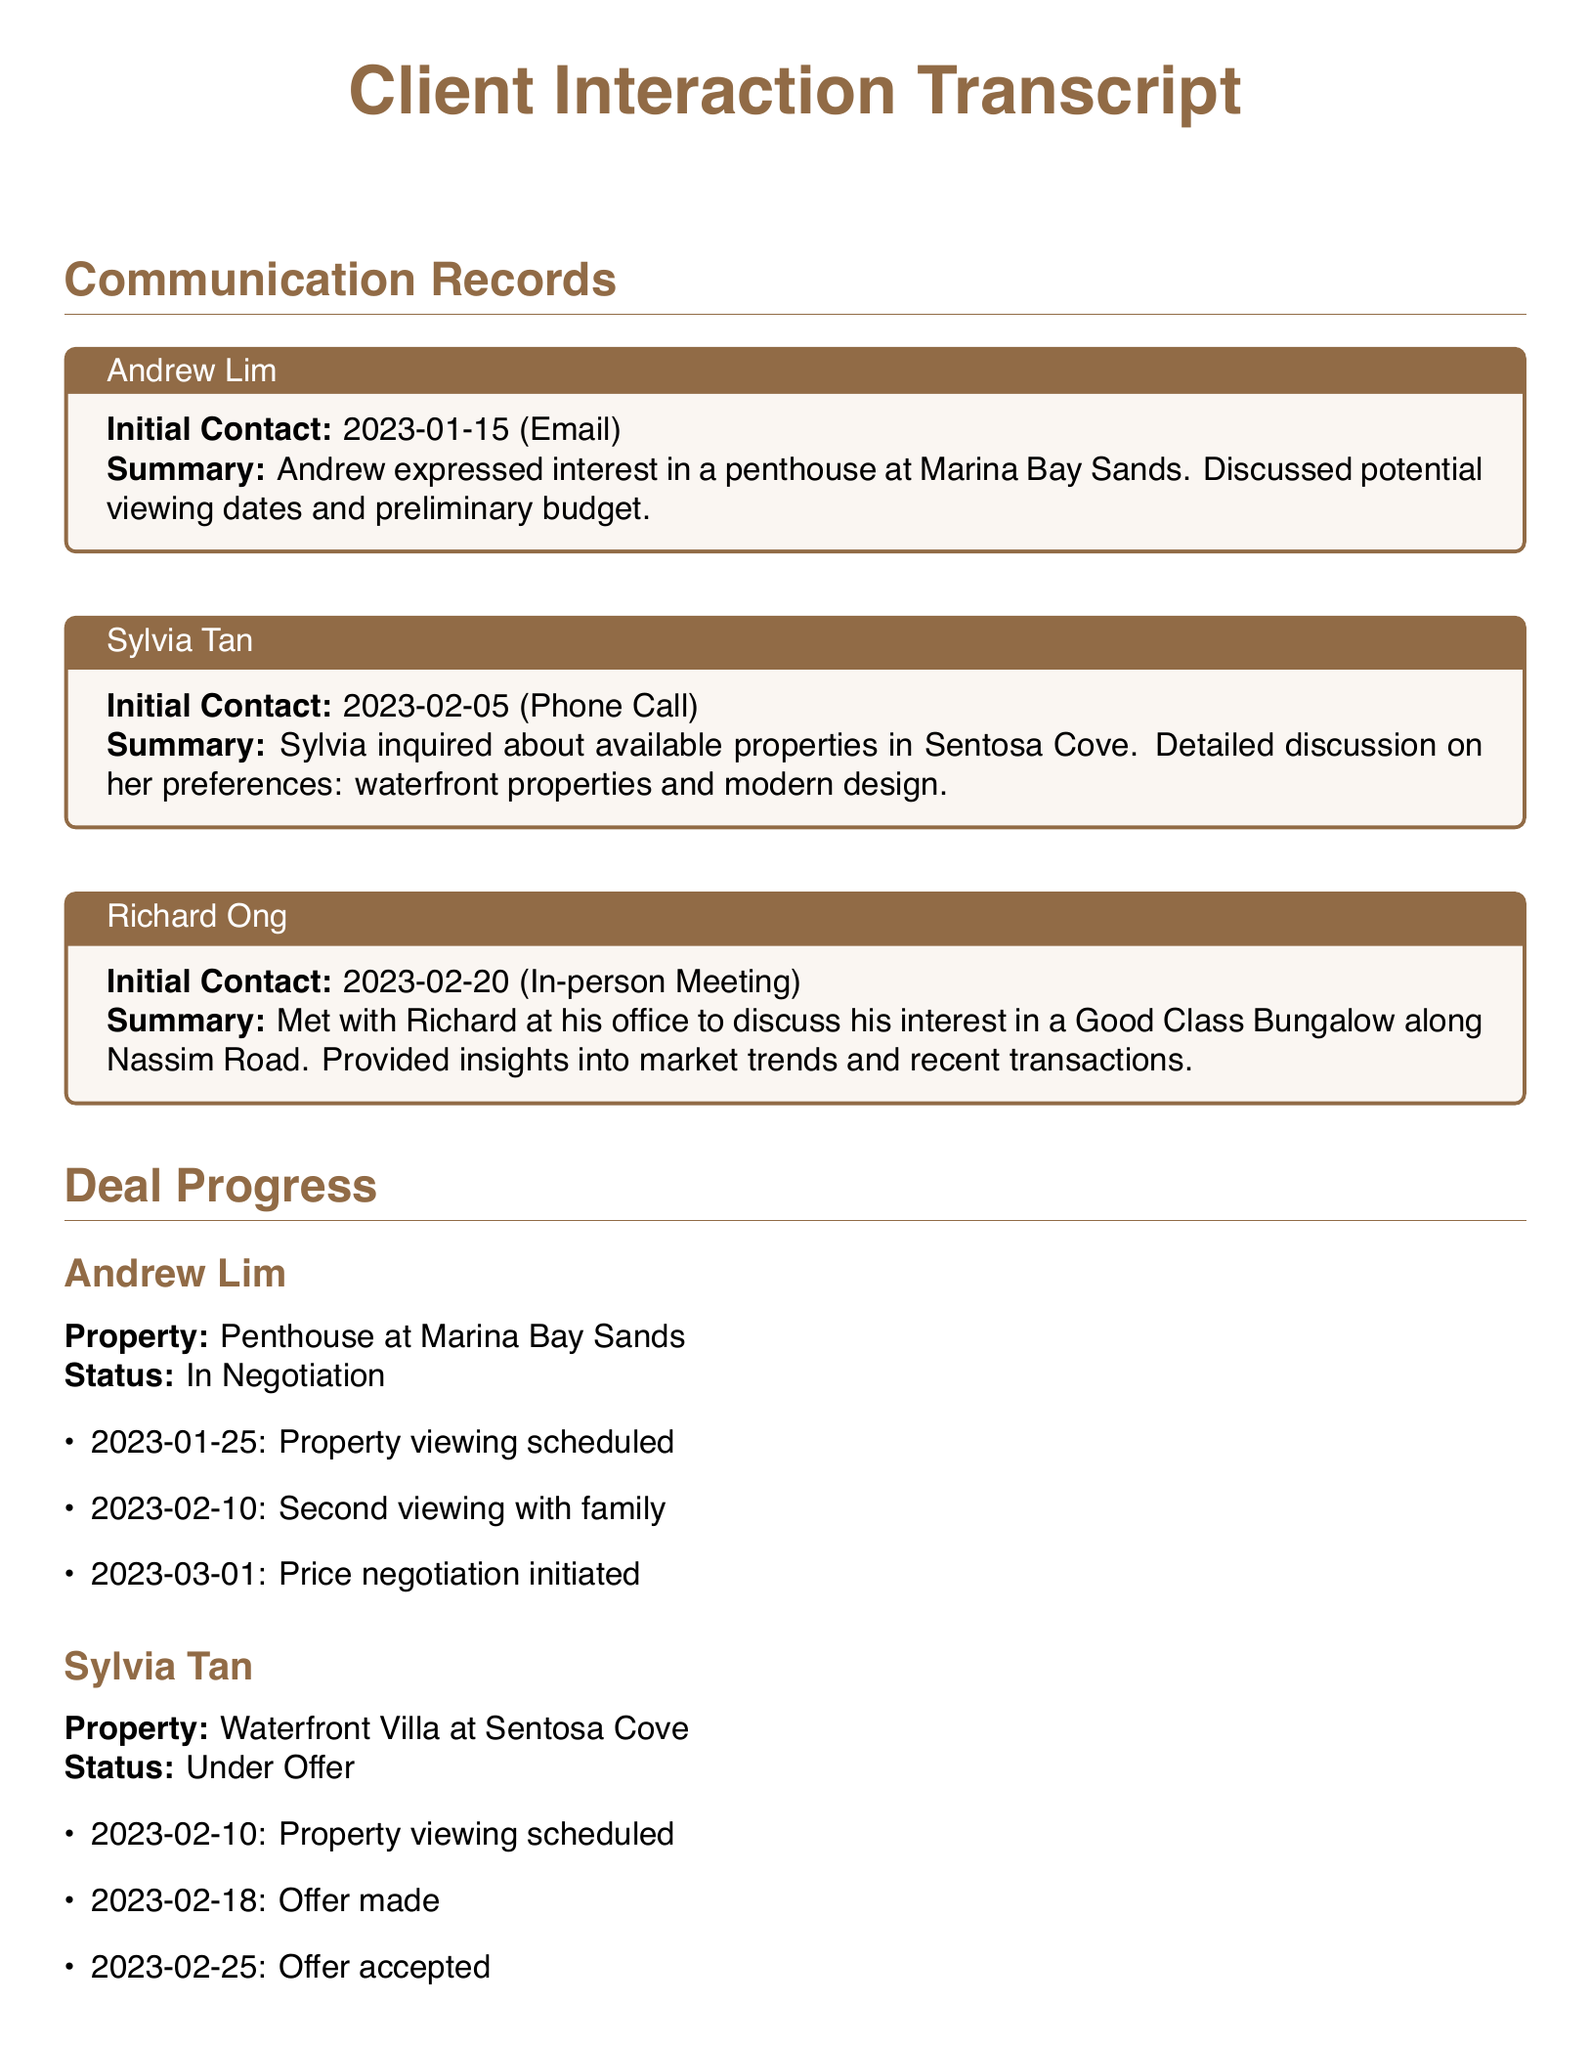What is the name of the first client listed? Andrew Lim is the first client mentioned in the communication records section of the document.
Answer: Andrew Lim When did Sylvia Tan make her initial contact? Sylvia Tan's initial contact was made on February 5, 2023, as noted in her communication record.
Answer: 2023-02-05 What is the status of Richard Ong's interest in the property? Richard Ong's status regarding his interest in the property is indicated as "Interest Registered."
Answer: Interest Registered How many viewings did Andrew Lim have scheduled? Andrew Lim had two property viewings scheduled, based on the details provided in the deal progress section.
Answer: 2 What type of property is Sylvia Tan interested in? Sylvia Tan expressed interest in a waterfront villa, as highlighted in her initial contact summary.
Answer: Waterfront Villa On what date was Sylvia Tan's offer accepted? The offer made by Sylvia Tan was accepted on February 25, 2023, as stated in her deal progress record.
Answer: 2023-02-25 What specific property is Richard Ong considering? Richard Ong is considering a Good Class Bungalow located along Nassim Road, as mentioned in his communication record.
Answer: Good Class Bungalow at Nassim Road What was discussed in Richard Ong's last follow-up? Richard Ong's last follow-up involved a discussion regarding renovation needs, as documented in the deal progress section.
Answer: Renovation needs What date was Andrew Lim's price negotiation initiated? The price negotiation for Andrew Lim was initiated on March 1, 2023, as noted in the deal progress.
Answer: 2023-03-01 